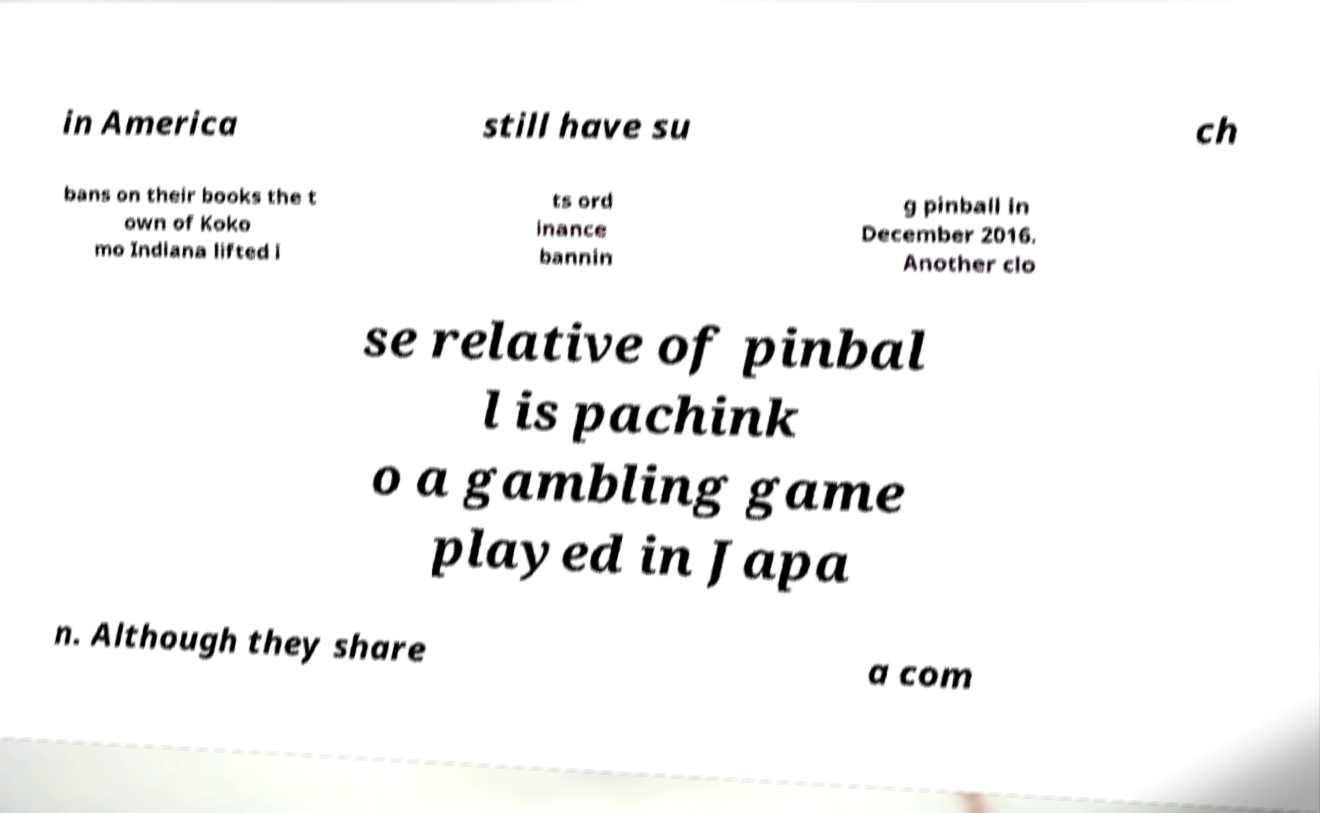Please identify and transcribe the text found in this image. in America still have su ch bans on their books the t own of Koko mo Indiana lifted i ts ord inance bannin g pinball in December 2016. Another clo se relative of pinbal l is pachink o a gambling game played in Japa n. Although they share a com 